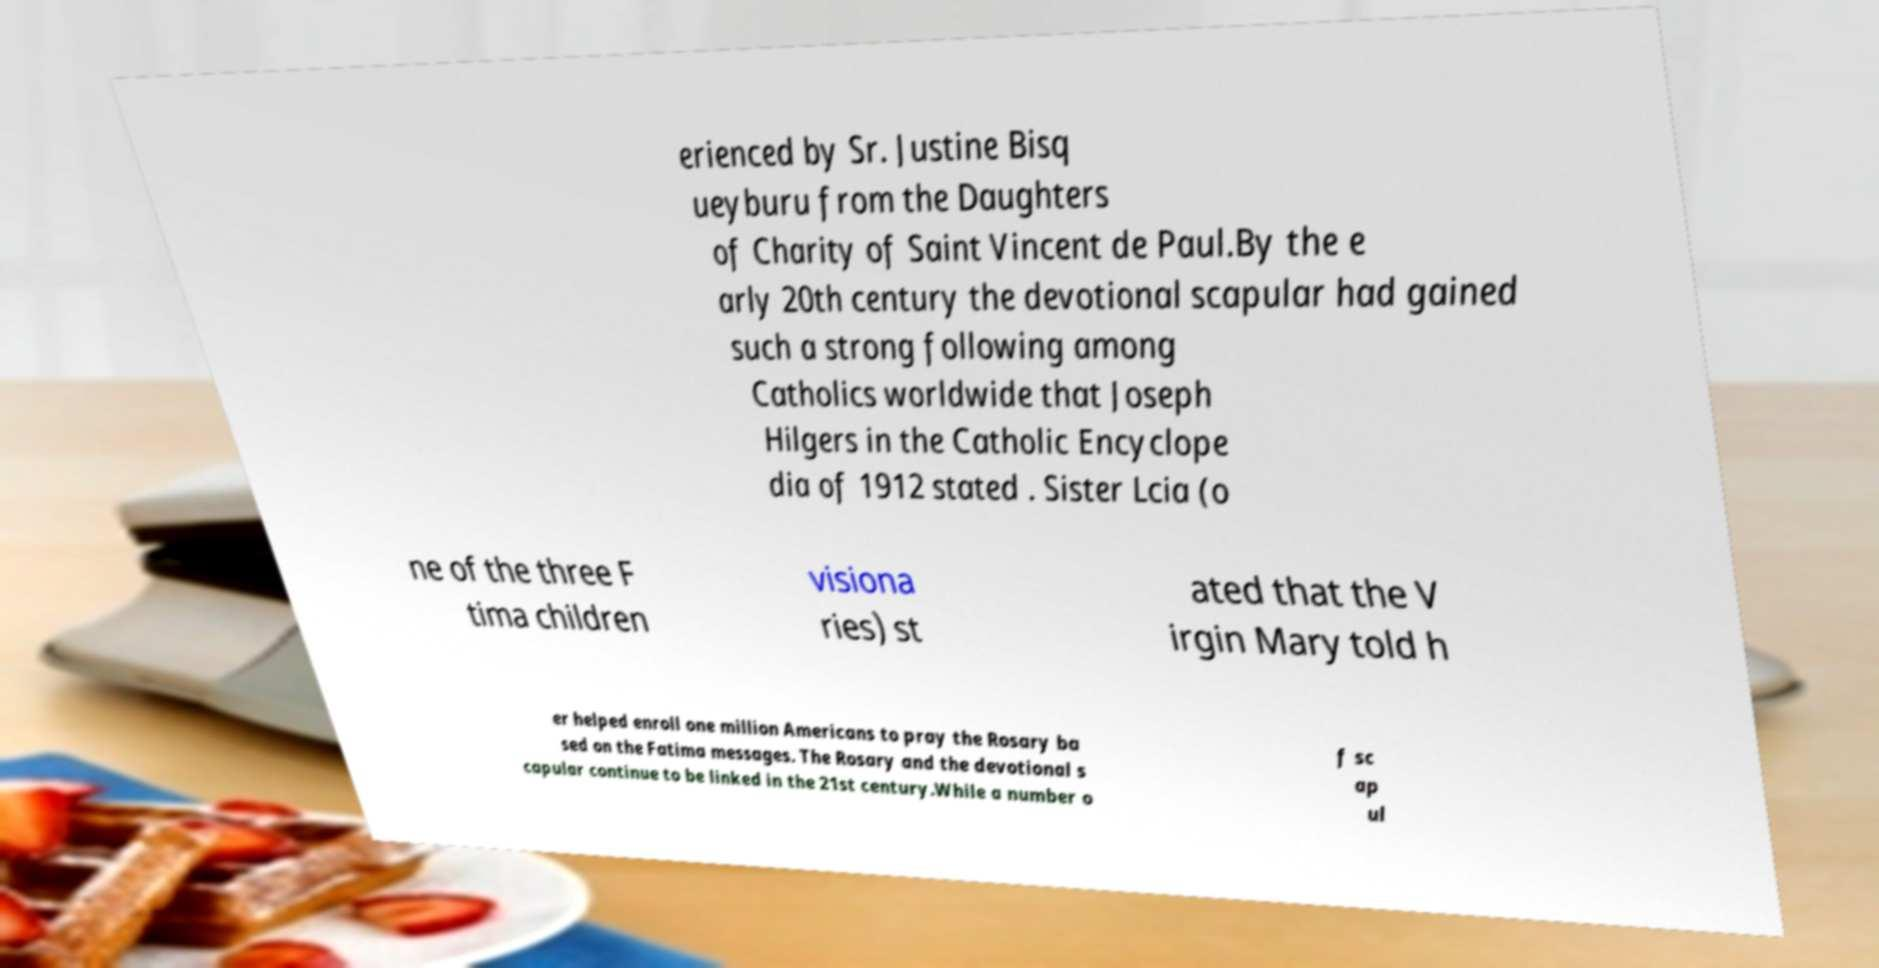Please identify and transcribe the text found in this image. erienced by Sr. Justine Bisq ueyburu from the Daughters of Charity of Saint Vincent de Paul.By the e arly 20th century the devotional scapular had gained such a strong following among Catholics worldwide that Joseph Hilgers in the Catholic Encyclope dia of 1912 stated . Sister Lcia (o ne of the three F tima children visiona ries) st ated that the V irgin Mary told h er helped enroll one million Americans to pray the Rosary ba sed on the Fatima messages. The Rosary and the devotional s capular continue to be linked in the 21st century.While a number o f sc ap ul 